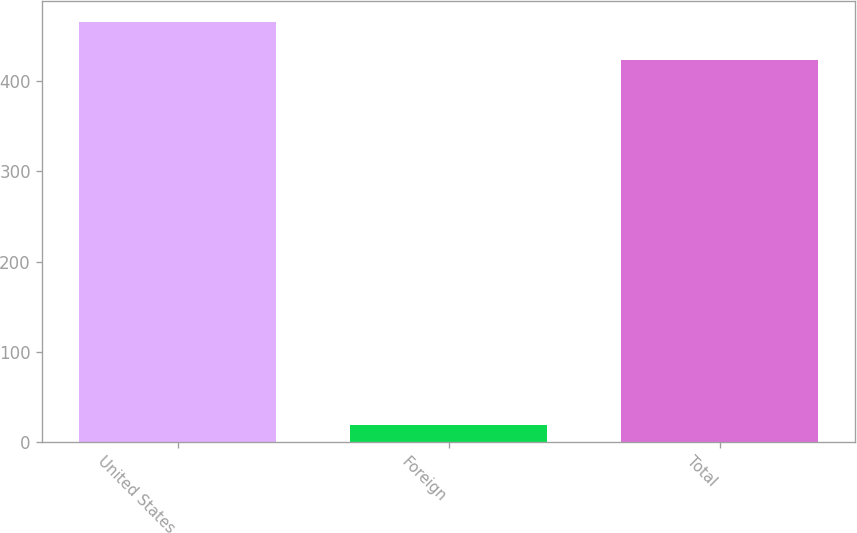Convert chart. <chart><loc_0><loc_0><loc_500><loc_500><bar_chart><fcel>United States<fcel>Foreign<fcel>Total<nl><fcel>465.3<fcel>19<fcel>423<nl></chart> 